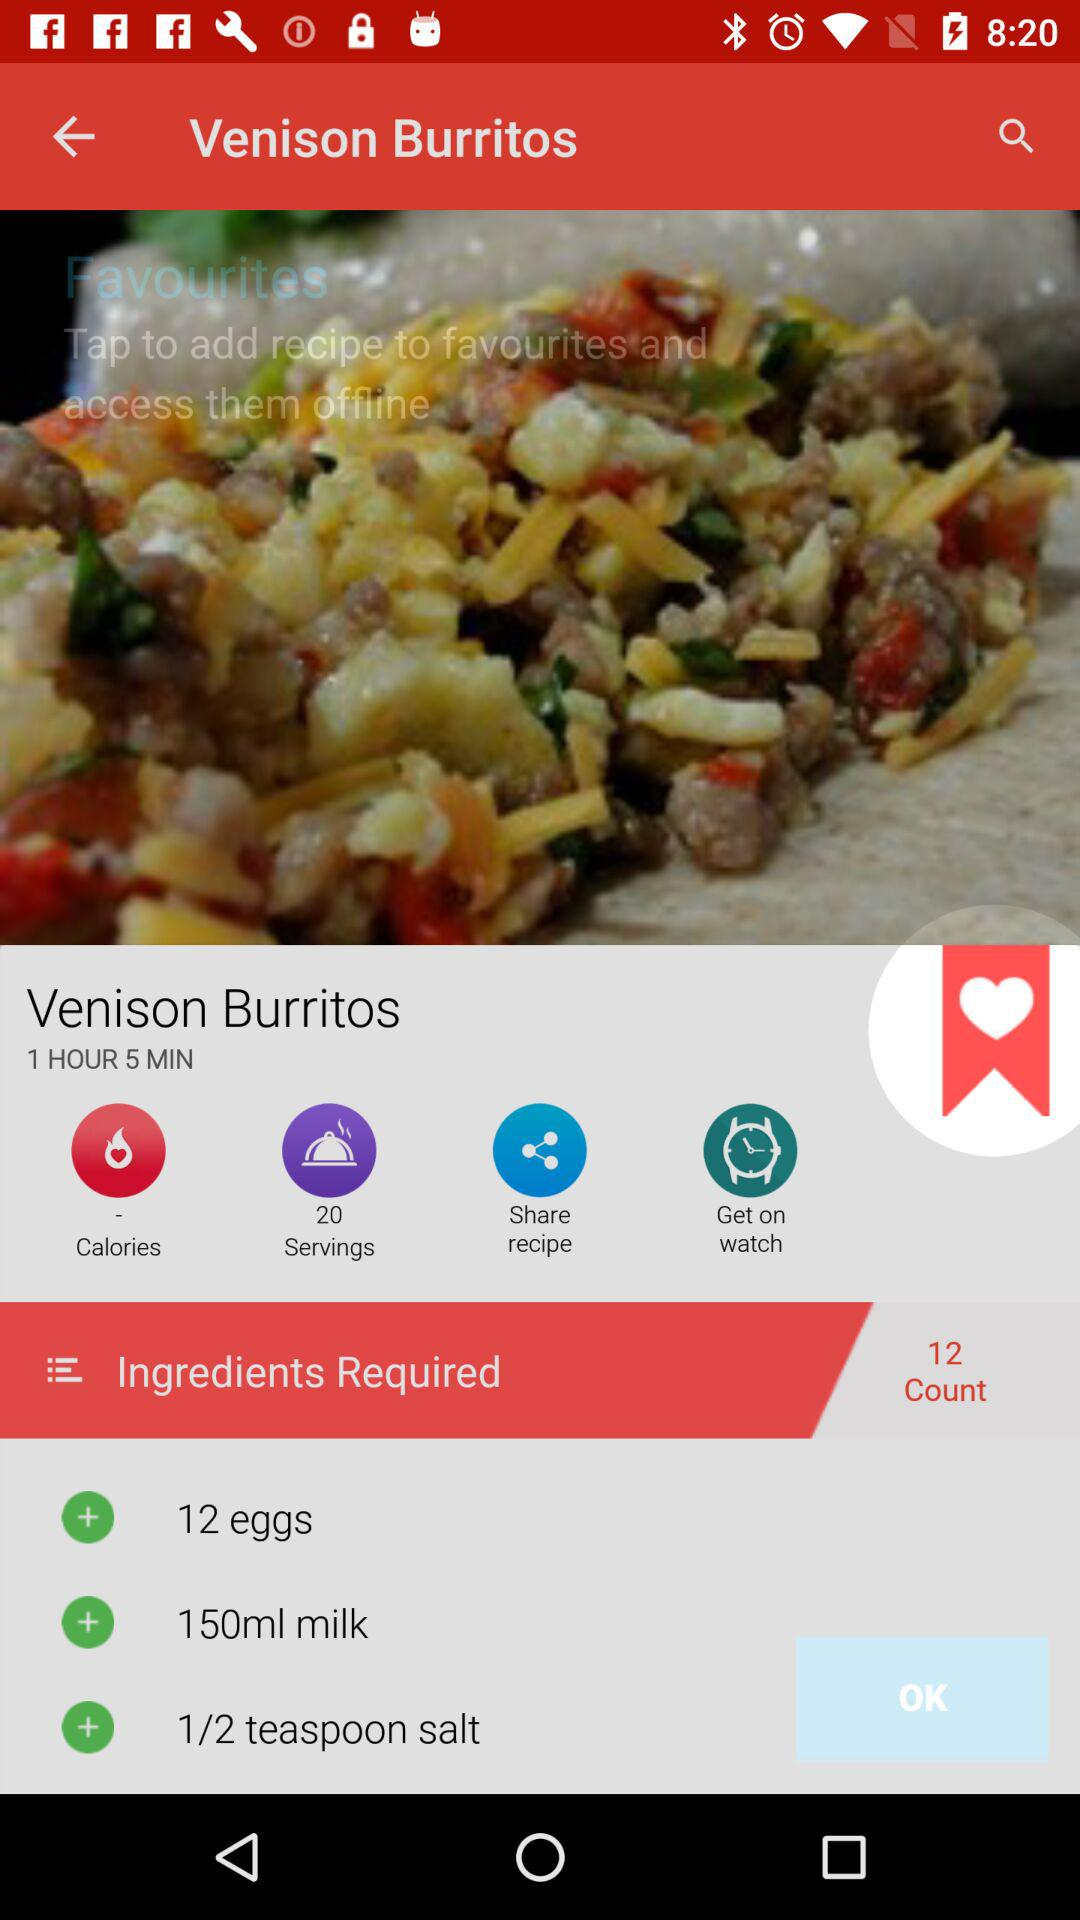How many minutes long is the recipe?
Answer the question using a single word or phrase. 1 hour 5 minutes 